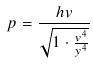Convert formula to latex. <formula><loc_0><loc_0><loc_500><loc_500>p = \frac { h v } { \sqrt { 1 \cdot \frac { v ^ { 4 } } { y ^ { 4 } } } }</formula> 